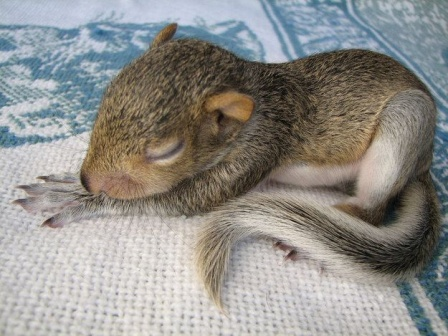Imagine a heartwarming story that could be associated with this image. Once upon a time, in a quaint forest, a gentle breeze carried a tiny baby squirrel to a welcoming blanket, carefully woven by forest spirits. The blanket, adorned with enchanting geometric patterns in hues of blue and white, was said to have magical properties. As the baby squirrel slumbered peacefully, the blanket wrapped it in a cocoon of warmth and protection, ensuring the little creature felt safe from harm. Forest animals gathered around, creating a circle of harmony and peace, watching over the sleeping squirrel as it dreamed of frolicking in meadows and climbing tall, majestic trees. This forest tableau remained a symbol of love, kindness, and the unspoken bond between nature's creatures, reminding all who came upon it of the importance of preserving these precious moments. 